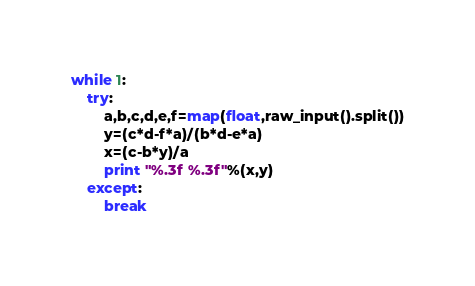<code> <loc_0><loc_0><loc_500><loc_500><_Python_>while 1:
    try:
        a,b,c,d,e,f=map(float,raw_input().split())
        y=(c*d-f*a)/(b*d-e*a)
        x=(c-b*y)/a
        print "%.3f %.3f"%(x,y)
    except:
        break</code> 